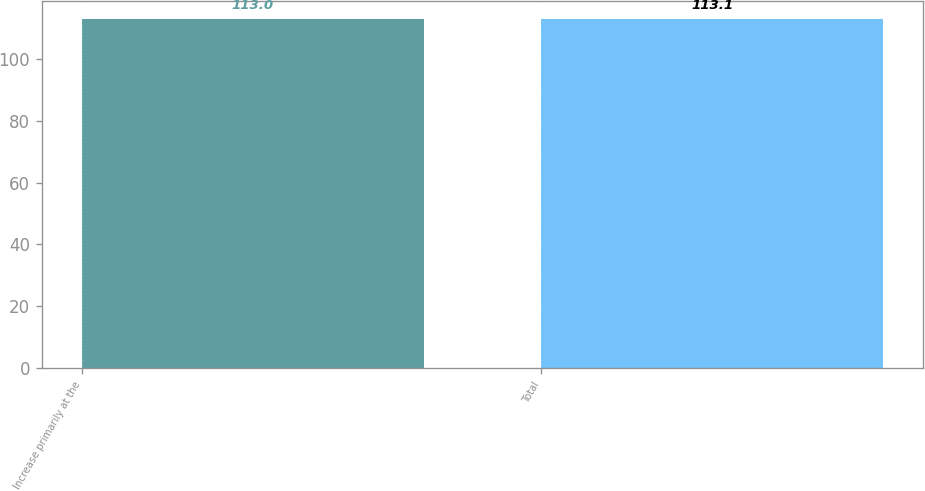<chart> <loc_0><loc_0><loc_500><loc_500><bar_chart><fcel>Increase primarily at the<fcel>Total<nl><fcel>113<fcel>113.1<nl></chart> 